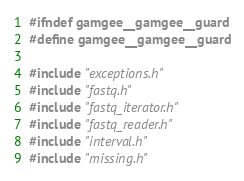Convert code to text. <code><loc_0><loc_0><loc_500><loc_500><_C_>#ifndef gamgee__gamgee__guard
#define gamgee__gamgee__guard

#include "exceptions.h"
#include "fastq.h"
#include "fastq_iterator.h"
#include "fastq_reader.h"
#include "interval.h"
#include "missing.h"</code> 